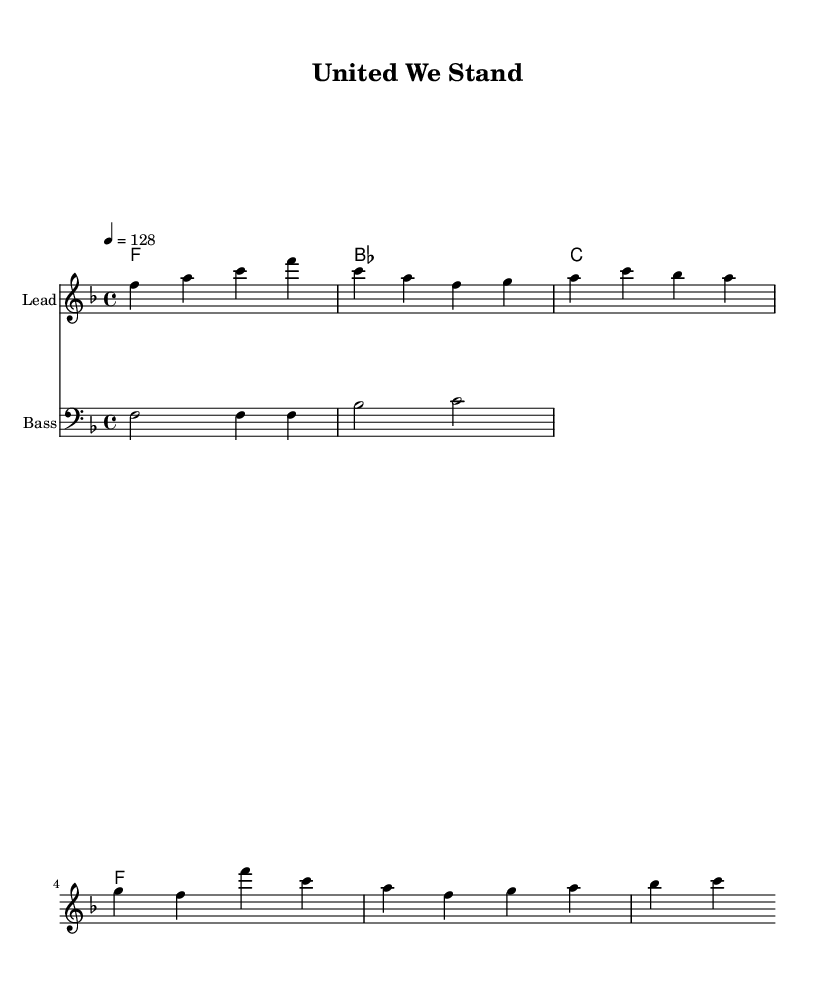What is the key signature of this music? The key signature is F major, which contains one flat (B flat). This can be seen in the key signature indicated at the beginning of the staff.
Answer: F major What is the time signature of this piece? The time signature is 4/4, which indicates that there are four beats in each measure and the quarter note receives one beat. This is shown at the start of the score where the time signature appears.
Answer: 4/4 What is the tempo marking in this music? The tempo marking is 128 beats per minute, which directs the performer to play at a moderate fast pace. This is indicated in the tempo directive found in the score.
Answer: 128 How many measures are in the melody? The melody consists of four measures, as indicated by the grouping of notes on the staff, each separated by vertical bars representing the measure boundaries.
Answer: Four What instrument is indicated for the leading staff? The instrument indicated for the leading staff is "Lead," which is noted in the staff's instrumentation label. This implies it is likely meant for a lead synth or vocal line, common in House music.
Answer: Lead What type of music is represented by this sheet? The sheet music represents House music, characterized by its tempo and electronic style. The uplifting nature and rhythmic structure, along with the title "United We Stand," suggest a patriotic theme appropriate for national celebrations.
Answer: House What is the bass clef note of the first measure? The first measure in the bass clef features the note F, shown on the first line of the bass staff. This defines the foundation of the harmonic structure and aligns with the key signature.
Answer: F 